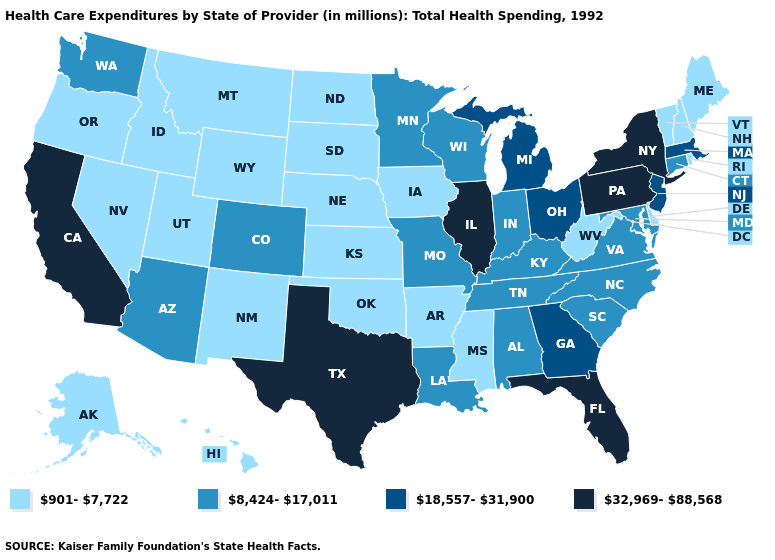Among the states that border Arkansas , does Louisiana have the highest value?
Answer briefly. No. Name the states that have a value in the range 901-7,722?
Concise answer only. Alaska, Arkansas, Delaware, Hawaii, Idaho, Iowa, Kansas, Maine, Mississippi, Montana, Nebraska, Nevada, New Hampshire, New Mexico, North Dakota, Oklahoma, Oregon, Rhode Island, South Dakota, Utah, Vermont, West Virginia, Wyoming. What is the value of Rhode Island?
Give a very brief answer. 901-7,722. What is the value of Georgia?
Short answer required. 18,557-31,900. Name the states that have a value in the range 8,424-17,011?
Quick response, please. Alabama, Arizona, Colorado, Connecticut, Indiana, Kentucky, Louisiana, Maryland, Minnesota, Missouri, North Carolina, South Carolina, Tennessee, Virginia, Washington, Wisconsin. Among the states that border New Jersey , which have the lowest value?
Concise answer only. Delaware. Does the map have missing data?
Concise answer only. No. Name the states that have a value in the range 32,969-88,568?
Short answer required. California, Florida, Illinois, New York, Pennsylvania, Texas. What is the value of Michigan?
Concise answer only. 18,557-31,900. What is the highest value in the USA?
Quick response, please. 32,969-88,568. Name the states that have a value in the range 18,557-31,900?
Be succinct. Georgia, Massachusetts, Michigan, New Jersey, Ohio. Name the states that have a value in the range 901-7,722?
Write a very short answer. Alaska, Arkansas, Delaware, Hawaii, Idaho, Iowa, Kansas, Maine, Mississippi, Montana, Nebraska, Nevada, New Hampshire, New Mexico, North Dakota, Oklahoma, Oregon, Rhode Island, South Dakota, Utah, Vermont, West Virginia, Wyoming. Name the states that have a value in the range 32,969-88,568?
Quick response, please. California, Florida, Illinois, New York, Pennsylvania, Texas. Name the states that have a value in the range 901-7,722?
Quick response, please. Alaska, Arkansas, Delaware, Hawaii, Idaho, Iowa, Kansas, Maine, Mississippi, Montana, Nebraska, Nevada, New Hampshire, New Mexico, North Dakota, Oklahoma, Oregon, Rhode Island, South Dakota, Utah, Vermont, West Virginia, Wyoming. Does Indiana have a lower value than Nevada?
Give a very brief answer. No. 